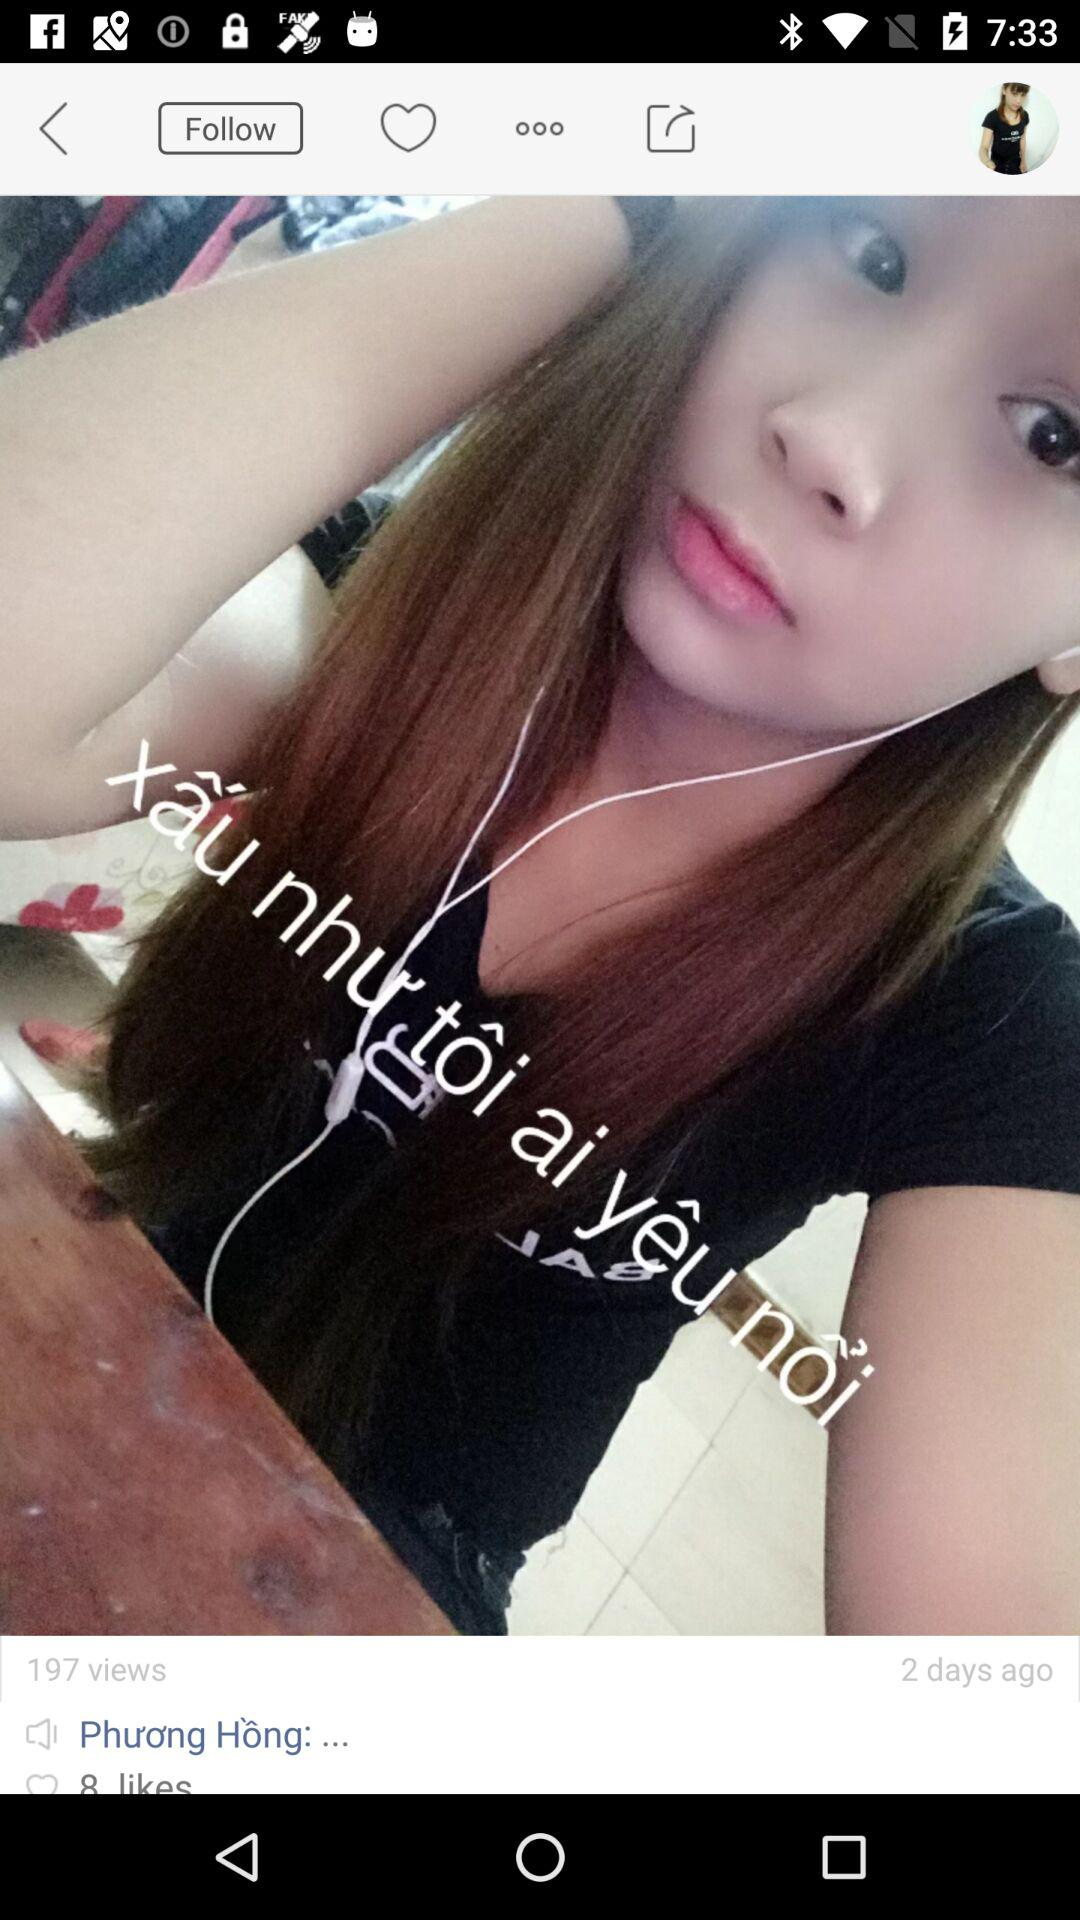What is the count of likes? The count is 8. 